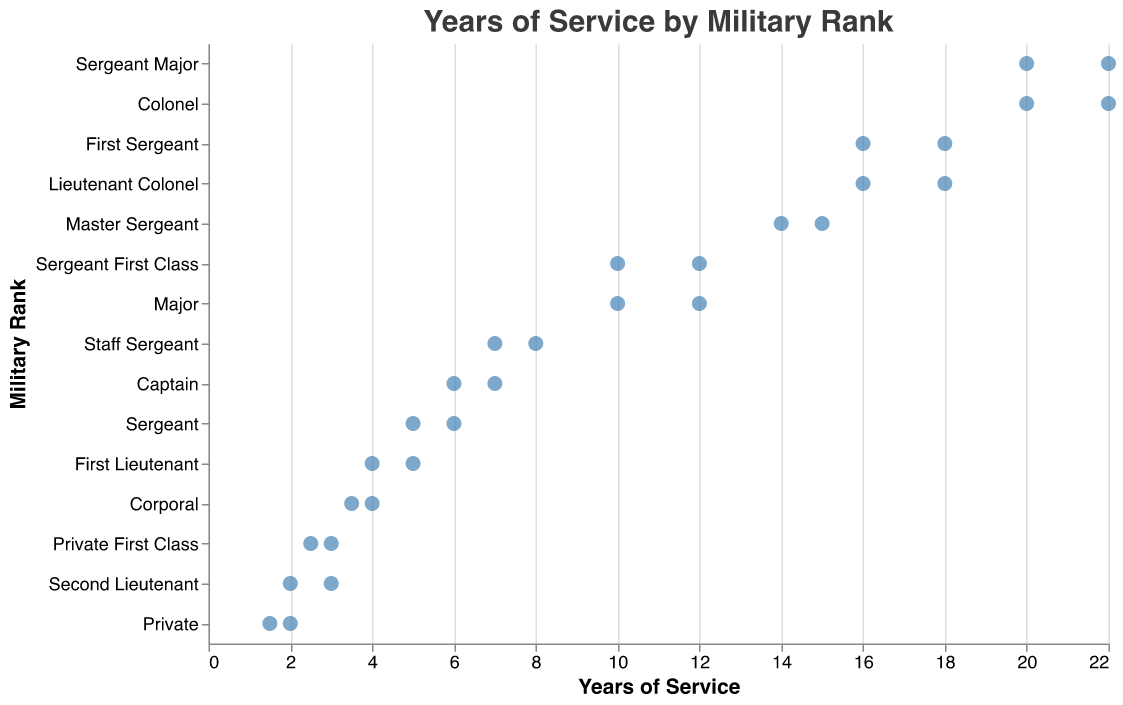What is the title of the plot? The title is always located at the top of the plot and it reads "Years of Service by Military Rank."
Answer: Years of Service by Military Rank Which rank has the most years of service shown in the plot? The plot shows the "Years of Service" on the x-axis and "Rank" on the y-axis. The highest value on the x-axis is associated with the ranks "Sergeant Major" and "Colonel" at 22 years.
Answer: Sergeant Major and Colonel What is the range of years of service for the rank of Captain? The plot points on the "Years of Service" axis corresponding to the "Captain" rank are 6 and 7 years. The range is calculated as 7 - 6 = 1 year.
Answer: 1 year Which rank has the smallest range of years of service displayed on the plot? To find the smallest range, we examine the difference between the maximum and minimum years for each rank. The ranks "Private" and "Second Lieutenant" both have the smallest range, each varying by only 1 year (2 - 1.5 and 3 - 2 respectively).
Answer: Private and Second Lieutenant What is the average years of service for the rank of Major? The plot shows two data points for "Major": 12 and 10 years of service. To find the average, calculate (12 + 10) / 2 = 11 years.
Answer: 11 years Which rank has more variation in terms of the number of years of service: "First Sergeant" or "Lieutenant Colonel"? To determine variation, we look at the range of service years. "First Sergeant" ranges from 16 to 18 years (2 years), and "Lieutenant Colonel" ranges from 16 to 18 years (also 2 years). Thus, both have the same variation.
Answer: Same variation How many ranks have at least one individual with more than 10 years of service? By counting all the ranks with points on the x-axis greater than 10, we find: "Sergeant First Class," "Master Sergeant," "First Sergeant," "Sergeant Major," "Major," "Lieutenant Colonel," and "Colonel," totaling 7 ranks.
Answer: 7 ranks 